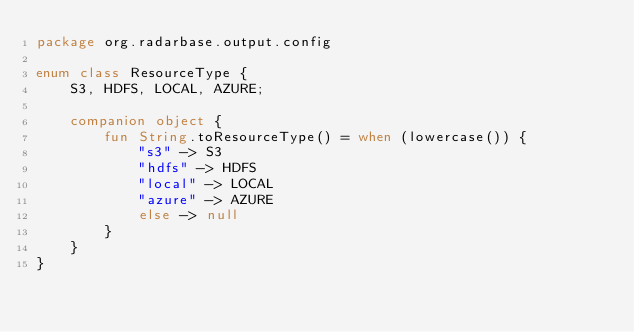Convert code to text. <code><loc_0><loc_0><loc_500><loc_500><_Kotlin_>package org.radarbase.output.config

enum class ResourceType {
    S3, HDFS, LOCAL, AZURE;

    companion object {
        fun String.toResourceType() = when (lowercase()) {
            "s3" -> S3
            "hdfs" -> HDFS
            "local" -> LOCAL
            "azure" -> AZURE
            else -> null
        }
    }
}
</code> 